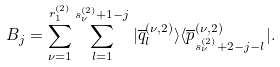Convert formula to latex. <formula><loc_0><loc_0><loc_500><loc_500>B _ { j } = \sum _ { \nu = 1 } ^ { r _ { 1 } ^ { ( 2 ) } } \sum _ { l = 1 } ^ { s _ { \nu } ^ { ( 2 ) } + 1 - j } | \overline { q } _ { l } ^ { ( \nu , 2 ) } \rangle \langle \overline { p } _ { s _ { \nu } ^ { ( 2 ) } + 2 - j - l } ^ { ( \nu , 2 ) } | .</formula> 